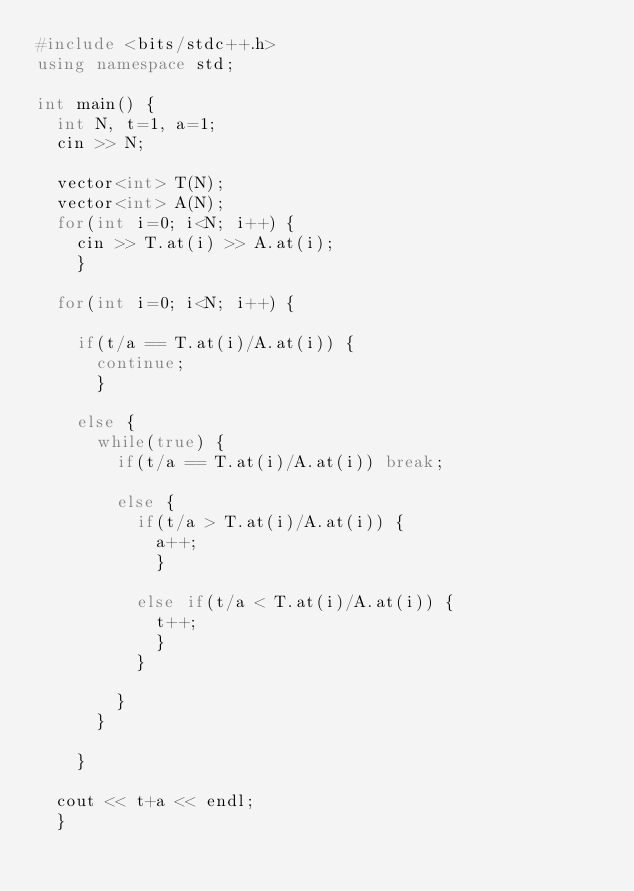Convert code to text. <code><loc_0><loc_0><loc_500><loc_500><_C++_>#include <bits/stdc++.h>
using namespace std;

int main() {
  int N, t=1, a=1;
  cin >> N;
  
  vector<int> T(N);
  vector<int> A(N);
  for(int i=0; i<N; i++) {
    cin >> T.at(i) >> A.at(i);
    }
  
  for(int i=0; i<N; i++) {
    
    if(t/a == T.at(i)/A.at(i)) {
      continue;
      }
    
    else {
      while(true) {
        if(t/a == T.at(i)/A.at(i)) break;
        
        else {
          if(t/a > T.at(i)/A.at(i)) {
            a++;
            }
        
          else if(t/a < T.at(i)/A.at(i)) {
            t++;
            }
          }
        
        }
      }
    
    }
  
  cout << t+a << endl;
  }</code> 